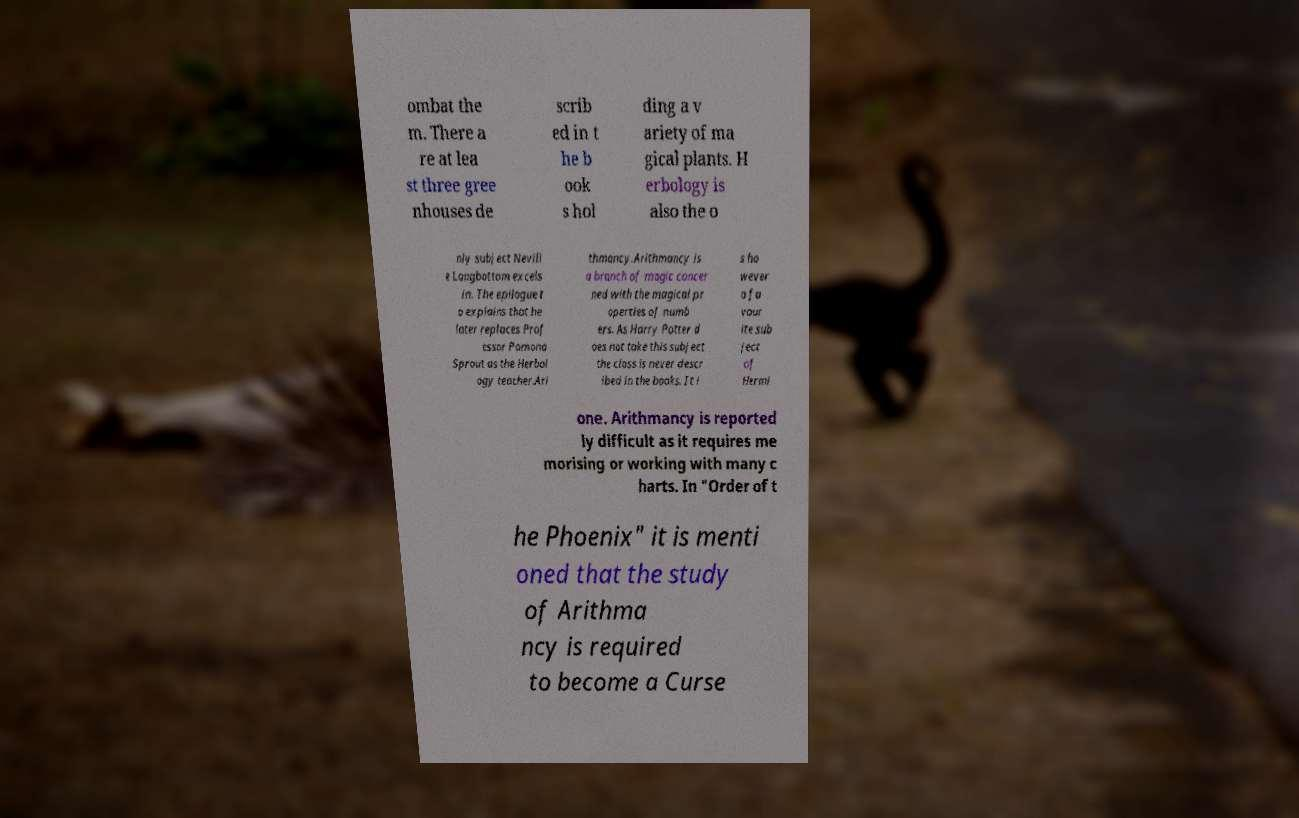There's text embedded in this image that I need extracted. Can you transcribe it verbatim? ombat the m. There a re at lea st three gree nhouses de scrib ed in t he b ook s hol ding a v ariety of ma gical plants. H erbology is also the o nly subject Nevill e Longbottom excels in. The epilogue t o explains that he later replaces Prof essor Pomona Sprout as the Herbol ogy teacher.Ari thmancy.Arithmancy is a branch of magic concer ned with the magical pr operties of numb ers. As Harry Potter d oes not take this subject the class is never descr ibed in the books. It i s ho wever a fa vour ite sub ject of Hermi one. Arithmancy is reported ly difficult as it requires me morising or working with many c harts. In "Order of t he Phoenix" it is menti oned that the study of Arithma ncy is required to become a Curse 